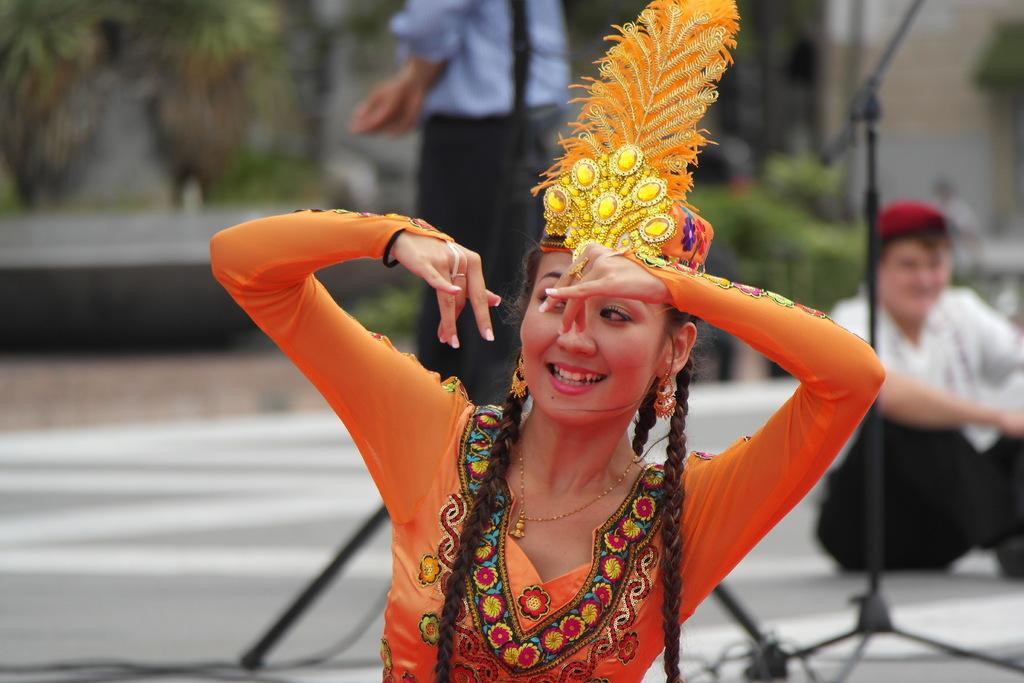How would you summarize this image in a sentence or two? In this picture we can see a woman is dancing in the front, on the right side there is a person sitting, in the background we can see plants, tripods and another person, we can see a blurry background. 